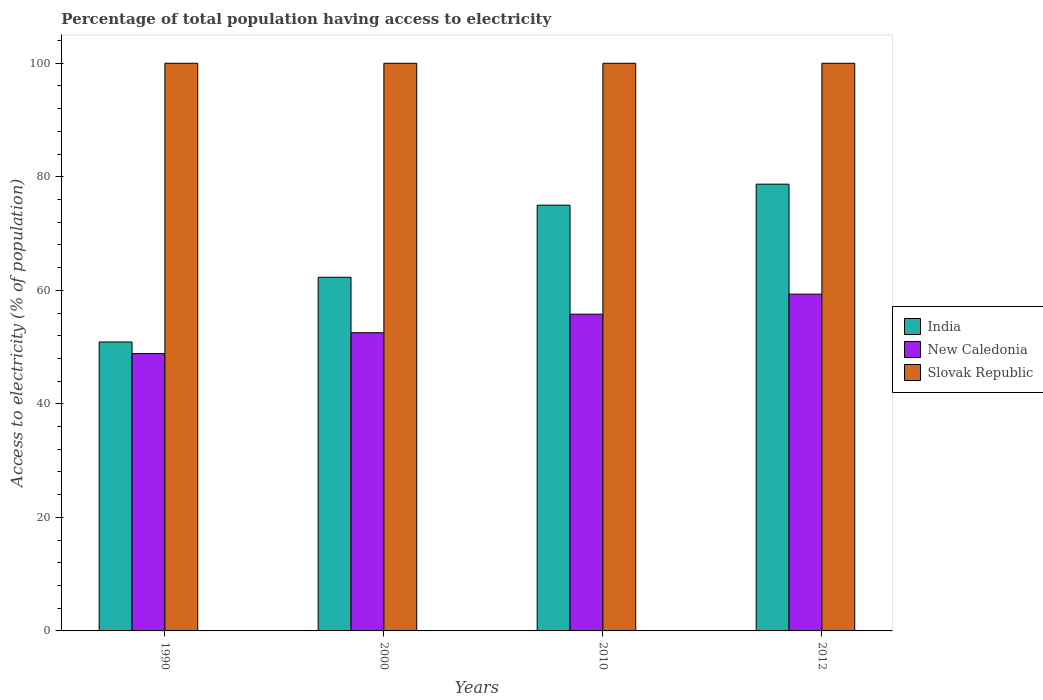How many groups of bars are there?
Offer a terse response. 4. How many bars are there on the 4th tick from the right?
Keep it short and to the point. 3. What is the percentage of population that have access to electricity in New Caledonia in 1990?
Provide a short and direct response. 48.86. Across all years, what is the maximum percentage of population that have access to electricity in Slovak Republic?
Provide a short and direct response. 100. Across all years, what is the minimum percentage of population that have access to electricity in New Caledonia?
Ensure brevity in your answer.  48.86. What is the total percentage of population that have access to electricity in Slovak Republic in the graph?
Offer a very short reply. 400. What is the difference between the percentage of population that have access to electricity in Slovak Republic in 1990 and that in 2010?
Your response must be concise. 0. What is the difference between the percentage of population that have access to electricity in New Caledonia in 2000 and the percentage of population that have access to electricity in Slovak Republic in 2012?
Ensure brevity in your answer.  -47.47. What is the average percentage of population that have access to electricity in India per year?
Give a very brief answer. 66.72. In the year 2010, what is the difference between the percentage of population that have access to electricity in New Caledonia and percentage of population that have access to electricity in Slovak Republic?
Your answer should be very brief. -44.2. In how many years, is the percentage of population that have access to electricity in New Caledonia greater than 32 %?
Provide a succinct answer. 4. What is the ratio of the percentage of population that have access to electricity in Slovak Republic in 2000 to that in 2012?
Your answer should be very brief. 1. Is the percentage of population that have access to electricity in New Caledonia in 2000 less than that in 2010?
Offer a terse response. Yes. Is the difference between the percentage of population that have access to electricity in New Caledonia in 1990 and 2000 greater than the difference between the percentage of population that have access to electricity in Slovak Republic in 1990 and 2000?
Make the answer very short. No. What is the difference between the highest and the second highest percentage of population that have access to electricity in India?
Your answer should be very brief. 3.7. What is the difference between the highest and the lowest percentage of population that have access to electricity in New Caledonia?
Make the answer very short. 10.47. In how many years, is the percentage of population that have access to electricity in Slovak Republic greater than the average percentage of population that have access to electricity in Slovak Republic taken over all years?
Make the answer very short. 0. Is the sum of the percentage of population that have access to electricity in Slovak Republic in 2000 and 2012 greater than the maximum percentage of population that have access to electricity in India across all years?
Your response must be concise. Yes. What does the 3rd bar from the left in 2000 represents?
Make the answer very short. Slovak Republic. What does the 1st bar from the right in 2010 represents?
Give a very brief answer. Slovak Republic. Are all the bars in the graph horizontal?
Your response must be concise. No. How many years are there in the graph?
Make the answer very short. 4. What is the difference between two consecutive major ticks on the Y-axis?
Your response must be concise. 20. Are the values on the major ticks of Y-axis written in scientific E-notation?
Make the answer very short. No. Where does the legend appear in the graph?
Offer a terse response. Center right. How many legend labels are there?
Ensure brevity in your answer.  3. How are the legend labels stacked?
Give a very brief answer. Vertical. What is the title of the graph?
Ensure brevity in your answer.  Percentage of total population having access to electricity. What is the label or title of the X-axis?
Provide a succinct answer. Years. What is the label or title of the Y-axis?
Your response must be concise. Access to electricity (% of population). What is the Access to electricity (% of population) of India in 1990?
Your answer should be very brief. 50.9. What is the Access to electricity (% of population) in New Caledonia in 1990?
Give a very brief answer. 48.86. What is the Access to electricity (% of population) of Slovak Republic in 1990?
Provide a succinct answer. 100. What is the Access to electricity (% of population) of India in 2000?
Your answer should be very brief. 62.3. What is the Access to electricity (% of population) in New Caledonia in 2000?
Your answer should be compact. 52.53. What is the Access to electricity (% of population) of New Caledonia in 2010?
Ensure brevity in your answer.  55.8. What is the Access to electricity (% of population) in Slovak Republic in 2010?
Provide a short and direct response. 100. What is the Access to electricity (% of population) in India in 2012?
Your answer should be compact. 78.7. What is the Access to electricity (% of population) in New Caledonia in 2012?
Your answer should be very brief. 59.33. What is the Access to electricity (% of population) of Slovak Republic in 2012?
Make the answer very short. 100. Across all years, what is the maximum Access to electricity (% of population) in India?
Keep it short and to the point. 78.7. Across all years, what is the maximum Access to electricity (% of population) in New Caledonia?
Make the answer very short. 59.33. Across all years, what is the maximum Access to electricity (% of population) of Slovak Republic?
Ensure brevity in your answer.  100. Across all years, what is the minimum Access to electricity (% of population) in India?
Offer a very short reply. 50.9. Across all years, what is the minimum Access to electricity (% of population) in New Caledonia?
Your response must be concise. 48.86. What is the total Access to electricity (% of population) of India in the graph?
Give a very brief answer. 266.9. What is the total Access to electricity (% of population) of New Caledonia in the graph?
Give a very brief answer. 216.52. What is the total Access to electricity (% of population) of Slovak Republic in the graph?
Keep it short and to the point. 400. What is the difference between the Access to electricity (% of population) of New Caledonia in 1990 and that in 2000?
Give a very brief answer. -3.67. What is the difference between the Access to electricity (% of population) of India in 1990 and that in 2010?
Ensure brevity in your answer.  -24.1. What is the difference between the Access to electricity (% of population) of New Caledonia in 1990 and that in 2010?
Offer a very short reply. -6.94. What is the difference between the Access to electricity (% of population) of Slovak Republic in 1990 and that in 2010?
Provide a short and direct response. 0. What is the difference between the Access to electricity (% of population) in India in 1990 and that in 2012?
Give a very brief answer. -27.8. What is the difference between the Access to electricity (% of population) of New Caledonia in 1990 and that in 2012?
Give a very brief answer. -10.47. What is the difference between the Access to electricity (% of population) of New Caledonia in 2000 and that in 2010?
Your response must be concise. -3.27. What is the difference between the Access to electricity (% of population) in Slovak Republic in 2000 and that in 2010?
Your response must be concise. 0. What is the difference between the Access to electricity (% of population) of India in 2000 and that in 2012?
Offer a very short reply. -16.4. What is the difference between the Access to electricity (% of population) of New Caledonia in 2000 and that in 2012?
Provide a succinct answer. -6.8. What is the difference between the Access to electricity (% of population) of Slovak Republic in 2000 and that in 2012?
Offer a terse response. 0. What is the difference between the Access to electricity (% of population) of New Caledonia in 2010 and that in 2012?
Ensure brevity in your answer.  -3.53. What is the difference between the Access to electricity (% of population) in India in 1990 and the Access to electricity (% of population) in New Caledonia in 2000?
Offer a very short reply. -1.63. What is the difference between the Access to electricity (% of population) in India in 1990 and the Access to electricity (% of population) in Slovak Republic in 2000?
Your answer should be very brief. -49.1. What is the difference between the Access to electricity (% of population) of New Caledonia in 1990 and the Access to electricity (% of population) of Slovak Republic in 2000?
Ensure brevity in your answer.  -51.14. What is the difference between the Access to electricity (% of population) of India in 1990 and the Access to electricity (% of population) of New Caledonia in 2010?
Your answer should be compact. -4.9. What is the difference between the Access to electricity (% of population) of India in 1990 and the Access to electricity (% of population) of Slovak Republic in 2010?
Your answer should be compact. -49.1. What is the difference between the Access to electricity (% of population) of New Caledonia in 1990 and the Access to electricity (% of population) of Slovak Republic in 2010?
Make the answer very short. -51.14. What is the difference between the Access to electricity (% of population) in India in 1990 and the Access to electricity (% of population) in New Caledonia in 2012?
Keep it short and to the point. -8.43. What is the difference between the Access to electricity (% of population) in India in 1990 and the Access to electricity (% of population) in Slovak Republic in 2012?
Provide a short and direct response. -49.1. What is the difference between the Access to electricity (% of population) of New Caledonia in 1990 and the Access to electricity (% of population) of Slovak Republic in 2012?
Ensure brevity in your answer.  -51.14. What is the difference between the Access to electricity (% of population) in India in 2000 and the Access to electricity (% of population) in New Caledonia in 2010?
Keep it short and to the point. 6.5. What is the difference between the Access to electricity (% of population) of India in 2000 and the Access to electricity (% of population) of Slovak Republic in 2010?
Keep it short and to the point. -37.7. What is the difference between the Access to electricity (% of population) in New Caledonia in 2000 and the Access to electricity (% of population) in Slovak Republic in 2010?
Ensure brevity in your answer.  -47.47. What is the difference between the Access to electricity (% of population) in India in 2000 and the Access to electricity (% of population) in New Caledonia in 2012?
Offer a terse response. 2.97. What is the difference between the Access to electricity (% of population) in India in 2000 and the Access to electricity (% of population) in Slovak Republic in 2012?
Provide a short and direct response. -37.7. What is the difference between the Access to electricity (% of population) of New Caledonia in 2000 and the Access to electricity (% of population) of Slovak Republic in 2012?
Provide a short and direct response. -47.47. What is the difference between the Access to electricity (% of population) of India in 2010 and the Access to electricity (% of population) of New Caledonia in 2012?
Your answer should be very brief. 15.67. What is the difference between the Access to electricity (% of population) in India in 2010 and the Access to electricity (% of population) in Slovak Republic in 2012?
Your response must be concise. -25. What is the difference between the Access to electricity (% of population) in New Caledonia in 2010 and the Access to electricity (% of population) in Slovak Republic in 2012?
Your response must be concise. -44.2. What is the average Access to electricity (% of population) in India per year?
Keep it short and to the point. 66.72. What is the average Access to electricity (% of population) in New Caledonia per year?
Make the answer very short. 54.13. What is the average Access to electricity (% of population) in Slovak Republic per year?
Your answer should be compact. 100. In the year 1990, what is the difference between the Access to electricity (% of population) of India and Access to electricity (% of population) of New Caledonia?
Provide a short and direct response. 2.04. In the year 1990, what is the difference between the Access to electricity (% of population) of India and Access to electricity (% of population) of Slovak Republic?
Make the answer very short. -49.1. In the year 1990, what is the difference between the Access to electricity (% of population) in New Caledonia and Access to electricity (% of population) in Slovak Republic?
Your answer should be compact. -51.14. In the year 2000, what is the difference between the Access to electricity (% of population) of India and Access to electricity (% of population) of New Caledonia?
Offer a terse response. 9.77. In the year 2000, what is the difference between the Access to electricity (% of population) of India and Access to electricity (% of population) of Slovak Republic?
Provide a succinct answer. -37.7. In the year 2000, what is the difference between the Access to electricity (% of population) in New Caledonia and Access to electricity (% of population) in Slovak Republic?
Provide a short and direct response. -47.47. In the year 2010, what is the difference between the Access to electricity (% of population) in India and Access to electricity (% of population) in New Caledonia?
Offer a terse response. 19.2. In the year 2010, what is the difference between the Access to electricity (% of population) in New Caledonia and Access to electricity (% of population) in Slovak Republic?
Provide a succinct answer. -44.2. In the year 2012, what is the difference between the Access to electricity (% of population) of India and Access to electricity (% of population) of New Caledonia?
Offer a terse response. 19.37. In the year 2012, what is the difference between the Access to electricity (% of population) in India and Access to electricity (% of population) in Slovak Republic?
Keep it short and to the point. -21.3. In the year 2012, what is the difference between the Access to electricity (% of population) of New Caledonia and Access to electricity (% of population) of Slovak Republic?
Make the answer very short. -40.67. What is the ratio of the Access to electricity (% of population) in India in 1990 to that in 2000?
Offer a very short reply. 0.82. What is the ratio of the Access to electricity (% of population) in New Caledonia in 1990 to that in 2000?
Your answer should be compact. 0.93. What is the ratio of the Access to electricity (% of population) in Slovak Republic in 1990 to that in 2000?
Offer a very short reply. 1. What is the ratio of the Access to electricity (% of population) of India in 1990 to that in 2010?
Provide a succinct answer. 0.68. What is the ratio of the Access to electricity (% of population) in New Caledonia in 1990 to that in 2010?
Provide a succinct answer. 0.88. What is the ratio of the Access to electricity (% of population) in India in 1990 to that in 2012?
Your response must be concise. 0.65. What is the ratio of the Access to electricity (% of population) in New Caledonia in 1990 to that in 2012?
Your answer should be compact. 0.82. What is the ratio of the Access to electricity (% of population) of Slovak Republic in 1990 to that in 2012?
Your answer should be very brief. 1. What is the ratio of the Access to electricity (% of population) in India in 2000 to that in 2010?
Your answer should be compact. 0.83. What is the ratio of the Access to electricity (% of population) in New Caledonia in 2000 to that in 2010?
Your answer should be compact. 0.94. What is the ratio of the Access to electricity (% of population) of Slovak Republic in 2000 to that in 2010?
Provide a succinct answer. 1. What is the ratio of the Access to electricity (% of population) in India in 2000 to that in 2012?
Provide a succinct answer. 0.79. What is the ratio of the Access to electricity (% of population) in New Caledonia in 2000 to that in 2012?
Give a very brief answer. 0.89. What is the ratio of the Access to electricity (% of population) of Slovak Republic in 2000 to that in 2012?
Provide a succinct answer. 1. What is the ratio of the Access to electricity (% of population) in India in 2010 to that in 2012?
Provide a succinct answer. 0.95. What is the ratio of the Access to electricity (% of population) in New Caledonia in 2010 to that in 2012?
Make the answer very short. 0.94. What is the difference between the highest and the second highest Access to electricity (% of population) of New Caledonia?
Give a very brief answer. 3.53. What is the difference between the highest and the lowest Access to electricity (% of population) of India?
Your answer should be compact. 27.8. What is the difference between the highest and the lowest Access to electricity (% of population) in New Caledonia?
Make the answer very short. 10.47. 